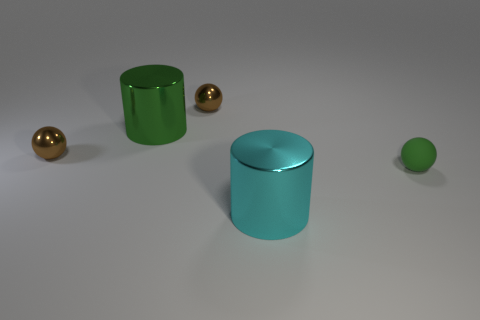Add 3 green objects. How many objects exist? 8 Subtract all cylinders. How many objects are left? 3 Subtract all big green cylinders. Subtract all tiny blue metal blocks. How many objects are left? 4 Add 1 tiny green spheres. How many tiny green spheres are left? 2 Add 4 green shiny cylinders. How many green shiny cylinders exist? 5 Subtract 1 cyan cylinders. How many objects are left? 4 